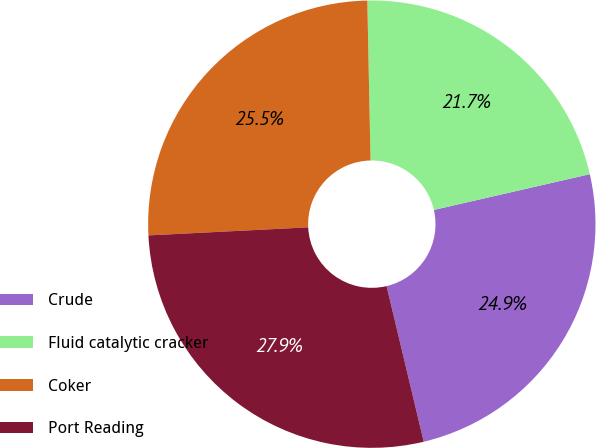Convert chart to OTSL. <chart><loc_0><loc_0><loc_500><loc_500><pie_chart><fcel>Crude<fcel>Fluid catalytic cracker<fcel>Coker<fcel>Port Reading<nl><fcel>24.86%<fcel>21.73%<fcel>25.48%<fcel>27.93%<nl></chart> 